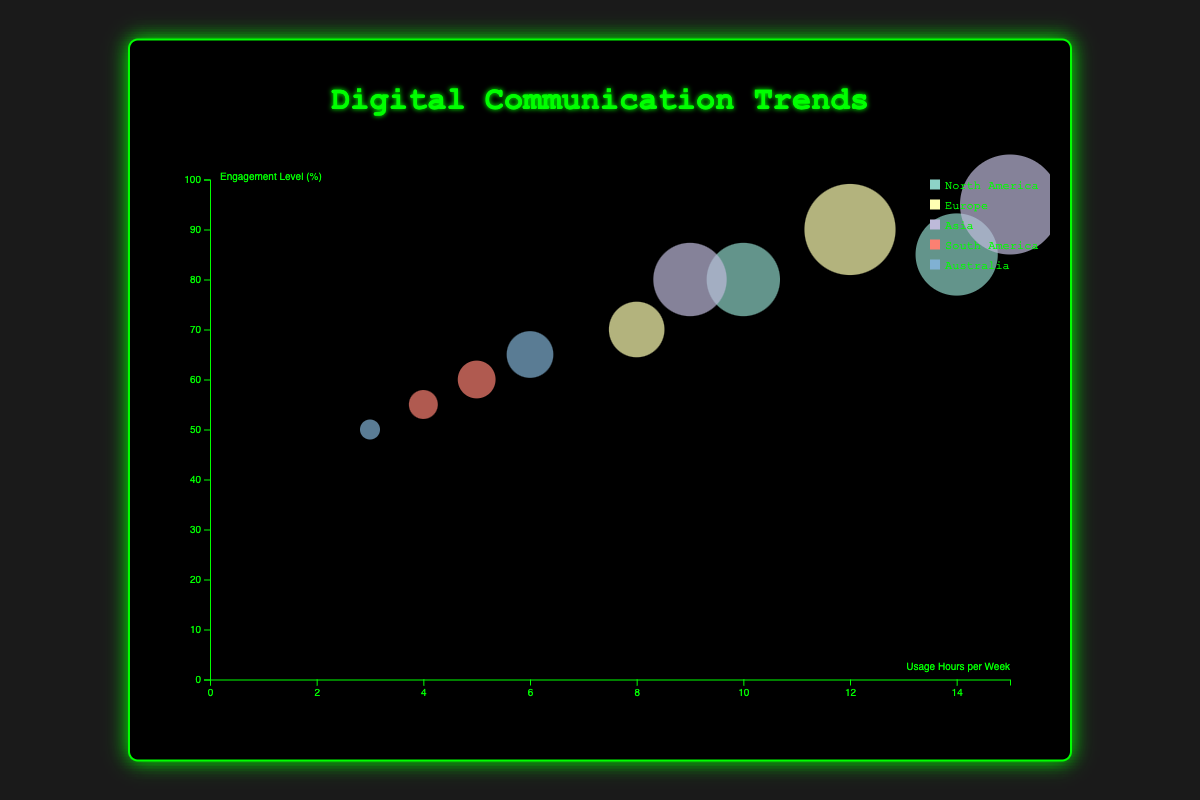Which age group and region combination has the highest engagement level? The highest engagement level can be found by looking at the y-axis and selecting the bubble that is highest on the chart. The bubble at the highest point (95%) represents the age group 35-44 in Asia using WeChat.
Answer: 35-44 in Asia What is the color associated with Europe in the chart? To find the color, you can refer to the legend box where each region is assigned a unique color. Look for Europe in the legend and check its color.
Answer: (Legend-specific color for Europe) How many age groups use WhatsApp across all regions? Check each bubble for the platform label that shows WhatsApp. Count the bubbles with WhatsApp across different regions: 25-34 in Europe, 45-54 in South America, and 55-64 in Australia.
Answer: 3 What platform is most used in the age group 18-24 in North America? Look at the bubbles representing the age group 18-24 in North America and compare their usage hours per week. The bubble with the highest usage (14 hours/week) represents Instagram.
Answer: Instagram How does the engagement level of the 25-34 age group in Europe on Facebook Messenger compare to WhatsApp? Find the bubbles for the 25-34 age group in Europe, then compare the engagement levels. Facebook Messenger has 70% and WhatsApp has 90%.
Answer: WhatsApp has a higher engagement level (90%) than Facebook Messenger (70%) Which platform shows the highest usage hours per week in Asia? Look at the bubbles representing the region Asia. Compare their usage hours per week on the x-axis. The bubble with the highest value represents WeChat with 15 hours/week.
Answer: WeChat What is the average usage hours per week for the 45-54 age group in South America? Sum the usage hours per week for the 45-54 age group bubbles in South America (5 for WhatsApp and 4 for Facebook Messenger) and divide by the number of these bubbles (2).
Answer: (5 + 4) / 2 = 4.5 hours/week Are there any communication methods other than text and if so, which region and platform use it? Check the bubbles for the "communication_method" attribute. Find non-text methods. Skype in Australia uses video communication.
Answer: Video method used by Skype in Australia Which region has the most diverse platforms in use? Compare the number of unique platforms per region by counting the distinct platforms in each bubble group per region. Asia has WeChat and LINE, total 2 platforms. Others have maximum 2 platforms as well.
Answer: No region stands out significantly over others in diversity of platforms What is the correlation between usage hours per week and engagement level for the 35-44 age group? Observe bubbles representing the 35-44 age group. WeChat has usage of 15 hours/week and 95% engagement, LINE has 9 hours/week and 80% engagement. Both show higher usage is generally associated with higher engagement.
Answer: Positive correlation 